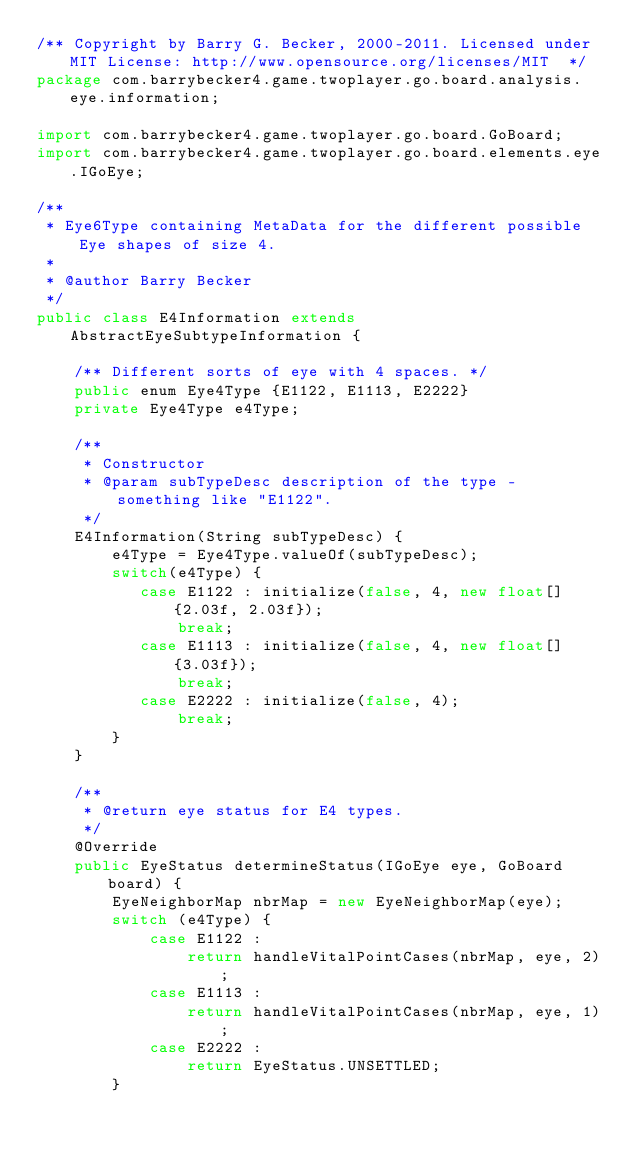Convert code to text. <code><loc_0><loc_0><loc_500><loc_500><_Java_>/** Copyright by Barry G. Becker, 2000-2011. Licensed under MIT License: http://www.opensource.org/licenses/MIT  */
package com.barrybecker4.game.twoplayer.go.board.analysis.eye.information;

import com.barrybecker4.game.twoplayer.go.board.GoBoard;
import com.barrybecker4.game.twoplayer.go.board.elements.eye.IGoEye;

/**
 * Eye6Type containing MetaData for the different possible Eye shapes of size 4.
 *
 * @author Barry Becker
 */
public class E4Information extends AbstractEyeSubtypeInformation {

    /** Different sorts of eye with 4 spaces. */
    public enum Eye4Type {E1122, E1113, E2222}
    private Eye4Type e4Type;

    /**
     * Constructor
     * @param subTypeDesc description of the type - something like "E1122".
     */
    E4Information(String subTypeDesc) {
        e4Type = Eye4Type.valueOf(subTypeDesc);
        switch(e4Type) {
           case E1122 : initialize(false, 4, new float[] {2.03f, 2.03f});
               break;
           case E1113 : initialize(false, 4, new float[] {3.03f});
               break;
           case E2222 : initialize(false, 4);
               break;
        }
    }

    /**
     * @return eye status for E4 types.
     */
    @Override
    public EyeStatus determineStatus(IGoEye eye, GoBoard board) {
        EyeNeighborMap nbrMap = new EyeNeighborMap(eye);
        switch (e4Type) {
            case E1122 :
                return handleVitalPointCases(nbrMap, eye, 2);
            case E1113 :
                return handleVitalPointCases(nbrMap, eye, 1);
            case E2222 :
                return EyeStatus.UNSETTLED;
        }</code> 